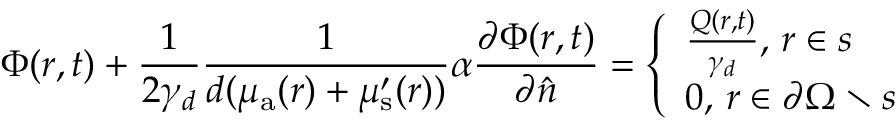<formula> <loc_0><loc_0><loc_500><loc_500>\Phi ( r , t ) + \frac { 1 } { 2 \gamma _ { d } } \frac { 1 } { d ( \mu _ { \mathrm a } ( r ) + \mu _ { s } ^ { \prime } ( r ) ) } \alpha \frac { \partial \Phi ( r , t ) } { \partial \hat { n } } = \left \{ \begin{array} { l } { \frac { Q ( r , t ) } { \gamma _ { d } } , \, r \in s } \\ { 0 , \, r \in \partial \Omega \ s } \end{array}</formula> 